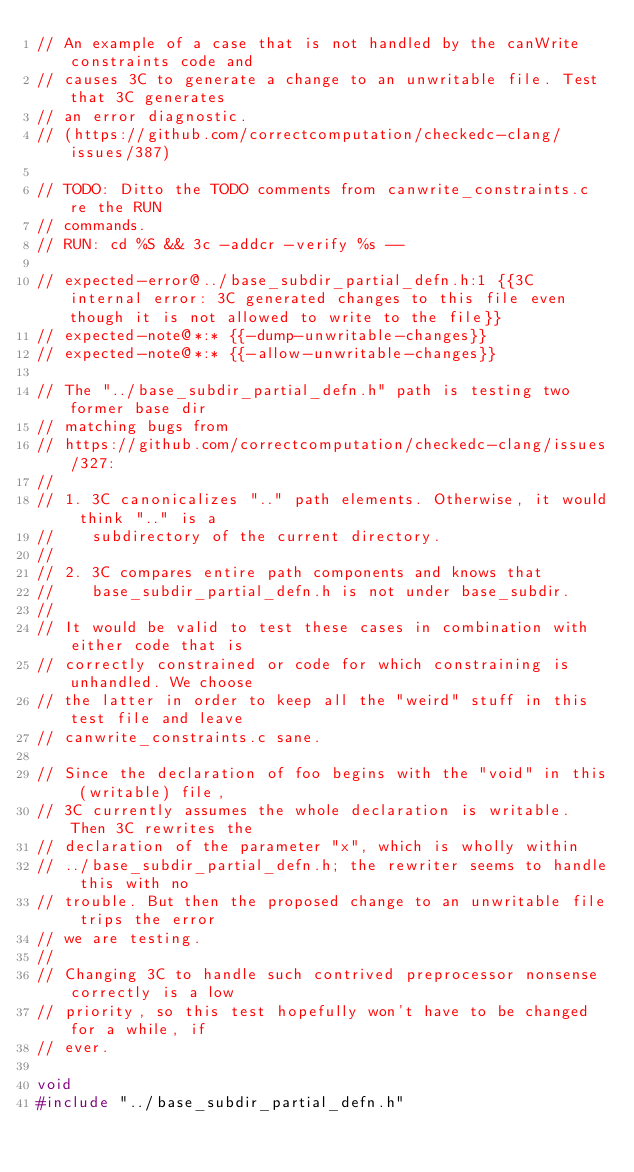Convert code to text. <code><loc_0><loc_0><loc_500><loc_500><_C_>// An example of a case that is not handled by the canWrite constraints code and
// causes 3C to generate a change to an unwritable file. Test that 3C generates
// an error diagnostic.
// (https://github.com/correctcomputation/checkedc-clang/issues/387)

// TODO: Ditto the TODO comments from canwrite_constraints.c re the RUN
// commands.
// RUN: cd %S && 3c -addcr -verify %s --

// expected-error@../base_subdir_partial_defn.h:1 {{3C internal error: 3C generated changes to this file even though it is not allowed to write to the file}}
// expected-note@*:* {{-dump-unwritable-changes}}
// expected-note@*:* {{-allow-unwritable-changes}}

// The "../base_subdir_partial_defn.h" path is testing two former base dir
// matching bugs from
// https://github.com/correctcomputation/checkedc-clang/issues/327:
//
// 1. 3C canonicalizes ".." path elements. Otherwise, it would think ".." is a
//    subdirectory of the current directory.
//
// 2. 3C compares entire path components and knows that
//    base_subdir_partial_defn.h is not under base_subdir.
//
// It would be valid to test these cases in combination with either code that is
// correctly constrained or code for which constraining is unhandled. We choose
// the latter in order to keep all the "weird" stuff in this test file and leave
// canwrite_constraints.c sane.

// Since the declaration of foo begins with the "void" in this (writable) file,
// 3C currently assumes the whole declaration is writable. Then 3C rewrites the
// declaration of the parameter "x", which is wholly within
// ../base_subdir_partial_defn.h; the rewriter seems to handle this with no
// trouble. But then the proposed change to an unwritable file trips the error
// we are testing.
//
// Changing 3C to handle such contrived preprocessor nonsense correctly is a low
// priority, so this test hopefully won't have to be changed for a while, if
// ever.

void
#include "../base_subdir_partial_defn.h"
</code> 